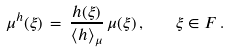Convert formula to latex. <formula><loc_0><loc_0><loc_500><loc_500>\mu ^ { h } ( \xi ) \, = \, \frac { h ( \xi ) } { \langle h \rangle _ { \mu } } \, \mu ( \xi ) \, , \quad \xi \in F \, .</formula> 